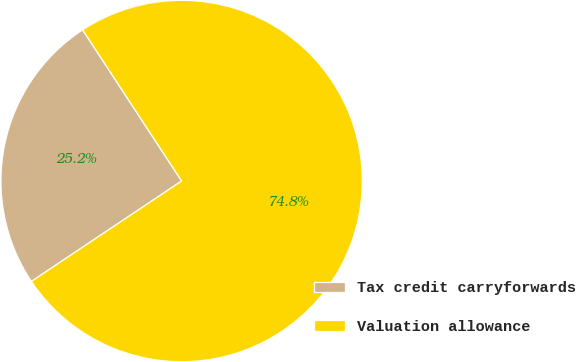<chart> <loc_0><loc_0><loc_500><loc_500><pie_chart><fcel>Tax credit carryforwards<fcel>Valuation allowance<nl><fcel>25.15%<fcel>74.85%<nl></chart> 